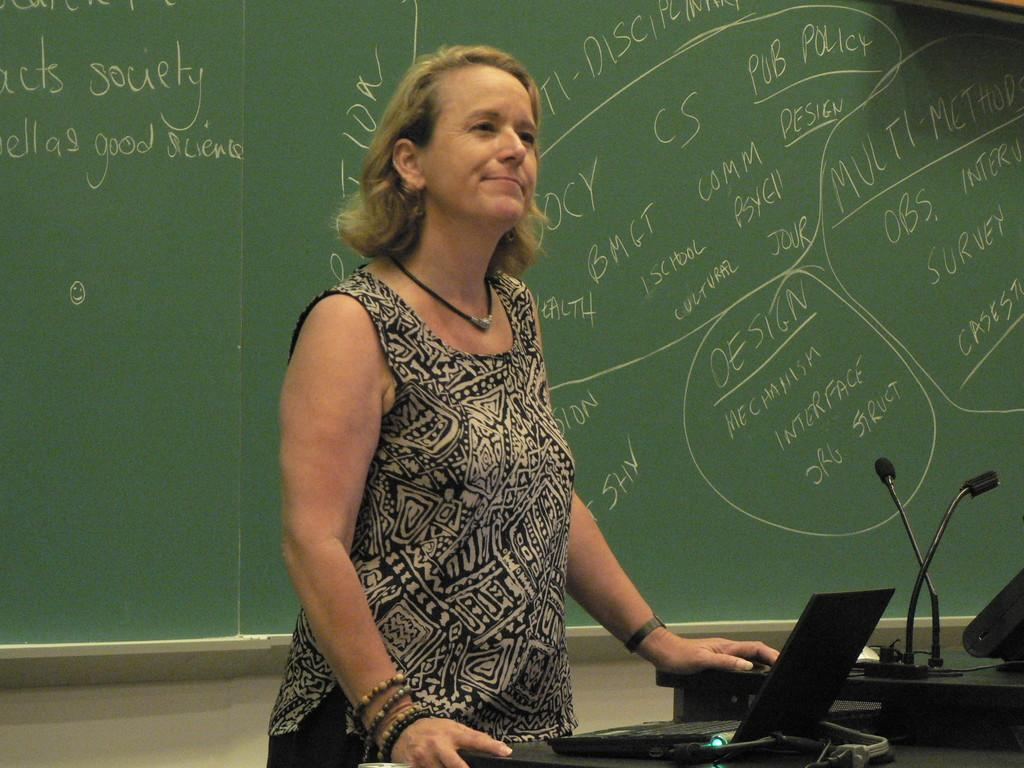Who is the main subject in the image? There is a woman in the image. What is the woman standing in front of? The woman is standing in front of a teaching board. What is the woman doing in the image? The woman is looking at someone. What type of songs can be heard in the background of the image? There is no audio or background music present in the image, so it is not possible to determine what songs might be heard. 